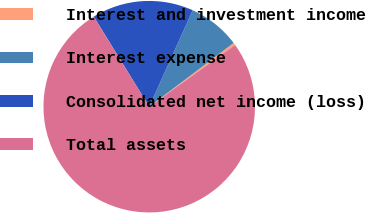Convert chart. <chart><loc_0><loc_0><loc_500><loc_500><pie_chart><fcel>Interest and investment income<fcel>Interest expense<fcel>Consolidated net income (loss)<fcel>Total assets<nl><fcel>0.39%<fcel>7.96%<fcel>15.53%<fcel>76.12%<nl></chart> 